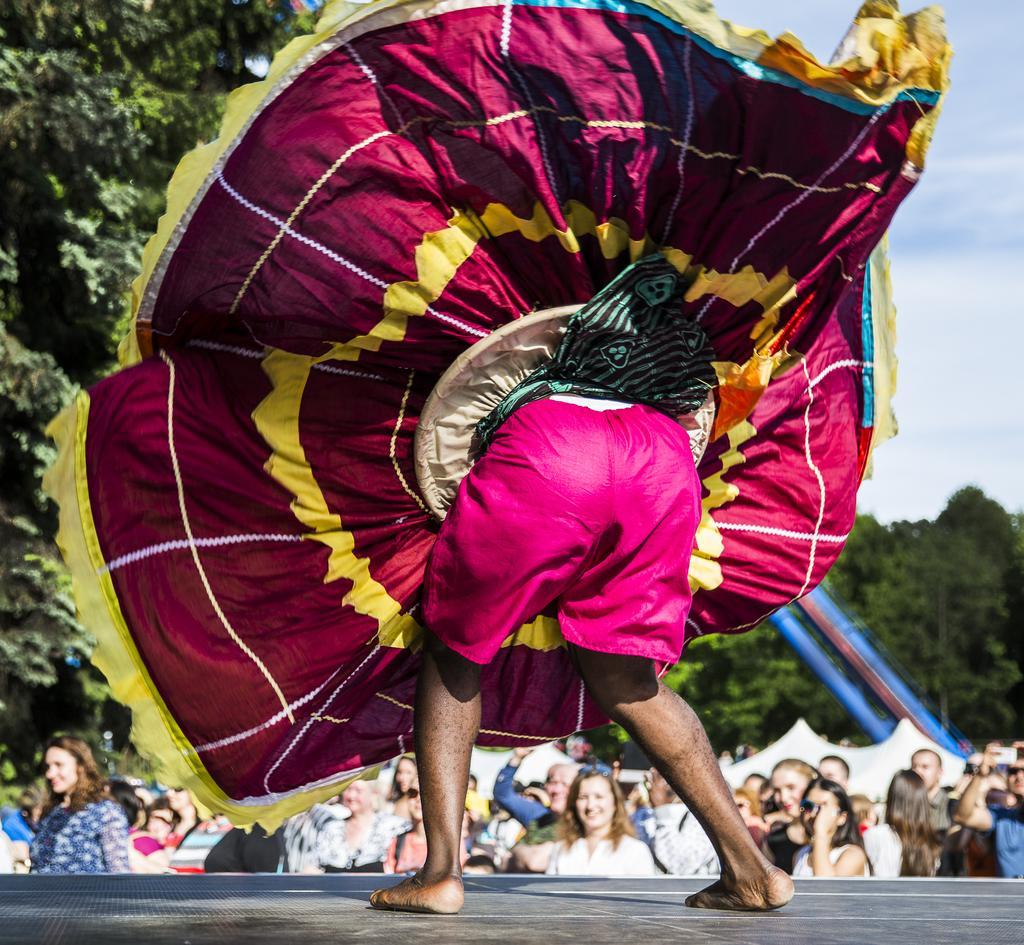How would you summarize this image in a sentence or two? In this image, we can see a person on the stage wearing costume and in the background, there are trees, tents and we can see people. At the top, there is sky. 